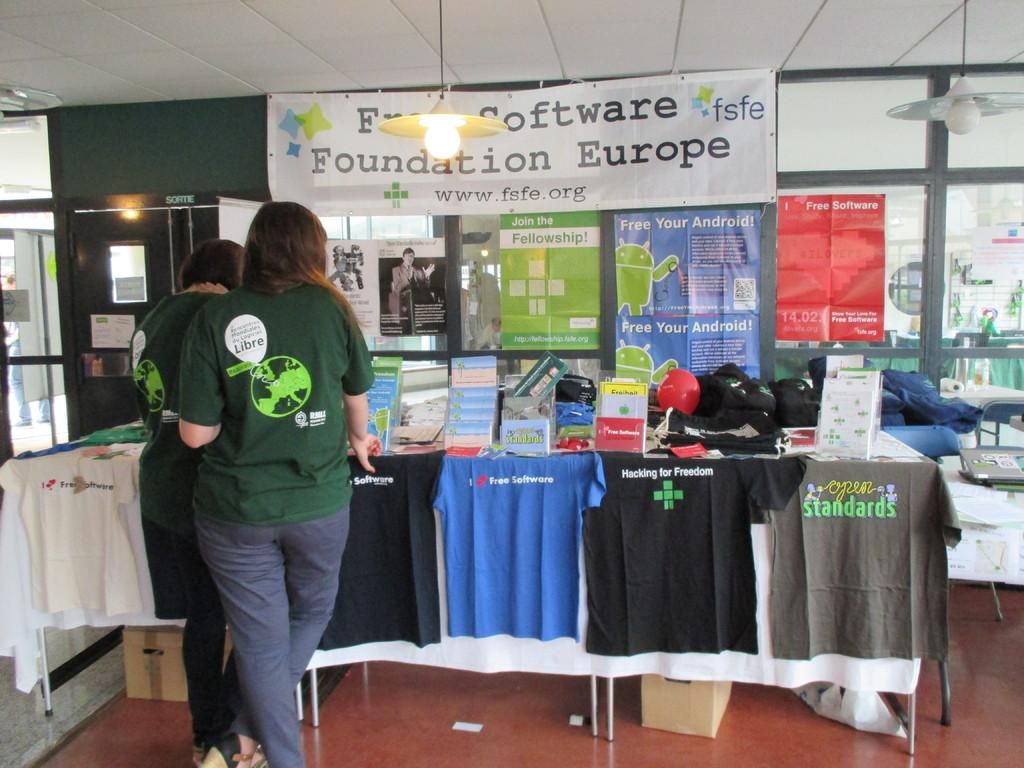<image>
Relay a brief, clear account of the picture shown. A woman standing at a display table under a sign that says Software Foundation Europe. 